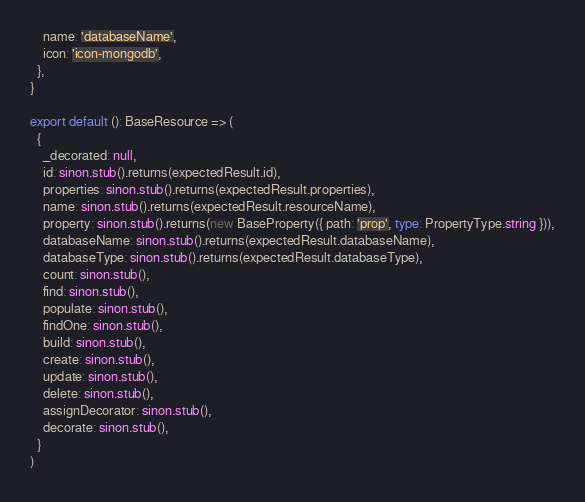<code> <loc_0><loc_0><loc_500><loc_500><_TypeScript_>    name: 'databaseName',
    icon: 'icon-mongodb',
  },
}

export default (): BaseResource => (
  {
    _decorated: null,
    id: sinon.stub().returns(expectedResult.id),
    properties: sinon.stub().returns(expectedResult.properties),
    name: sinon.stub().returns(expectedResult.resourceName),
    property: sinon.stub().returns(new BaseProperty({ path: 'prop', type: PropertyType.string })),
    databaseName: sinon.stub().returns(expectedResult.databaseName),
    databaseType: sinon.stub().returns(expectedResult.databaseType),
    count: sinon.stub(),
    find: sinon.stub(),
    populate: sinon.stub(),
    findOne: sinon.stub(),
    build: sinon.stub(),
    create: sinon.stub(),
    update: sinon.stub(),
    delete: sinon.stub(),
    assignDecorator: sinon.stub(),
    decorate: sinon.stub(),
  }
)
</code> 